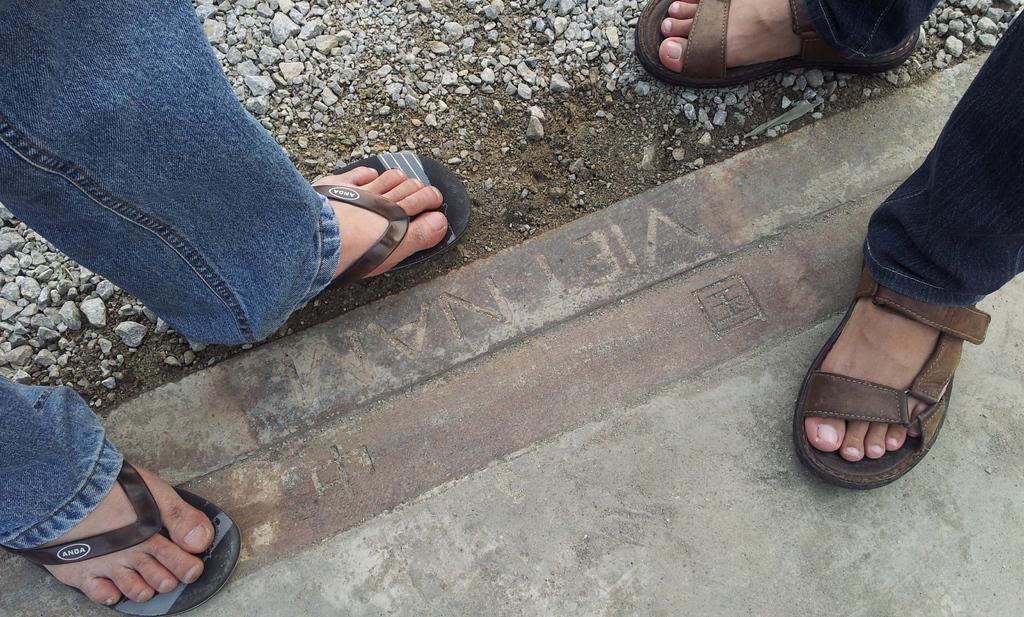Please provide a concise description of this image. In this picture we can see there are two people legs and stones on the platform. 